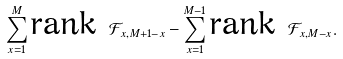Convert formula to latex. <formula><loc_0><loc_0><loc_500><loc_500>\sum _ { x = 1 } ^ { M } \text {rank } \mathcal { F } _ { x , M + 1 - x } - \sum _ { x = 1 } ^ { M - 1 } \text {rank } \mathcal { F } _ { x , M - x } .</formula> 